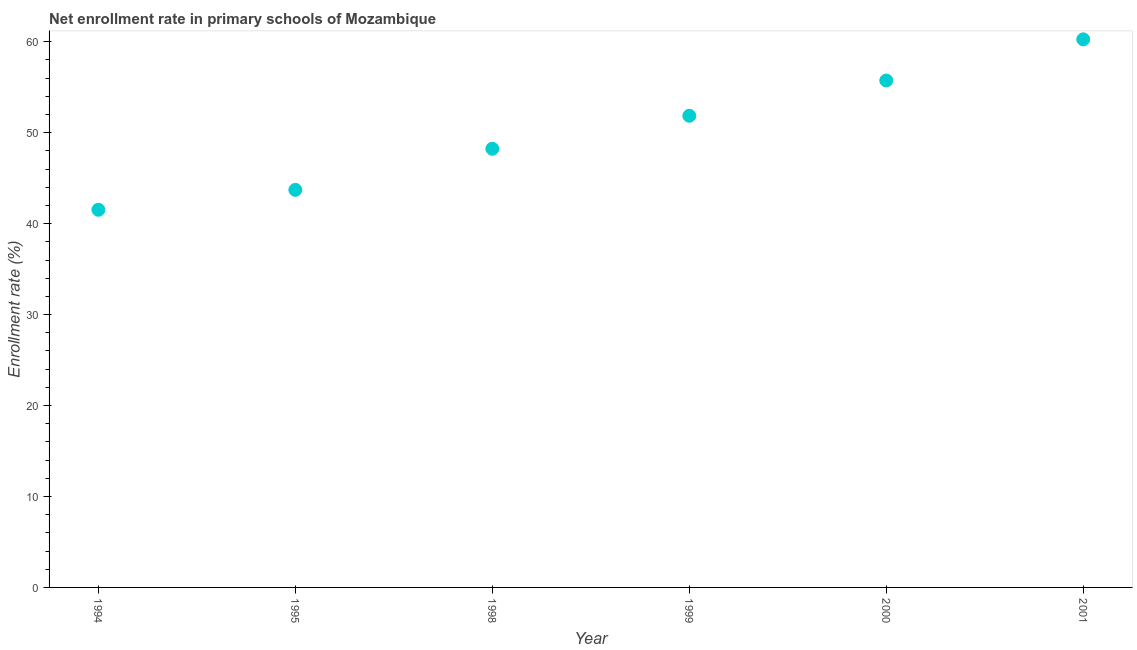What is the net enrollment rate in primary schools in 2001?
Your response must be concise. 60.26. Across all years, what is the maximum net enrollment rate in primary schools?
Your answer should be compact. 60.26. Across all years, what is the minimum net enrollment rate in primary schools?
Ensure brevity in your answer.  41.53. In which year was the net enrollment rate in primary schools minimum?
Provide a short and direct response. 1994. What is the sum of the net enrollment rate in primary schools?
Your response must be concise. 301.33. What is the difference between the net enrollment rate in primary schools in 1994 and 1999?
Your answer should be very brief. -10.34. What is the average net enrollment rate in primary schools per year?
Give a very brief answer. 50.22. What is the median net enrollment rate in primary schools?
Provide a short and direct response. 50.05. What is the ratio of the net enrollment rate in primary schools in 2000 to that in 2001?
Provide a short and direct response. 0.92. Is the net enrollment rate in primary schools in 1994 less than that in 2001?
Offer a terse response. Yes. What is the difference between the highest and the second highest net enrollment rate in primary schools?
Give a very brief answer. 4.53. What is the difference between the highest and the lowest net enrollment rate in primary schools?
Provide a short and direct response. 18.74. In how many years, is the net enrollment rate in primary schools greater than the average net enrollment rate in primary schools taken over all years?
Keep it short and to the point. 3. How many dotlines are there?
Offer a very short reply. 1. How many years are there in the graph?
Offer a very short reply. 6. What is the difference between two consecutive major ticks on the Y-axis?
Give a very brief answer. 10. Are the values on the major ticks of Y-axis written in scientific E-notation?
Make the answer very short. No. Does the graph contain any zero values?
Provide a short and direct response. No. Does the graph contain grids?
Make the answer very short. No. What is the title of the graph?
Provide a short and direct response. Net enrollment rate in primary schools of Mozambique. What is the label or title of the Y-axis?
Offer a terse response. Enrollment rate (%). What is the Enrollment rate (%) in 1994?
Provide a succinct answer. 41.53. What is the Enrollment rate (%) in 1995?
Ensure brevity in your answer.  43.71. What is the Enrollment rate (%) in 1998?
Your answer should be very brief. 48.23. What is the Enrollment rate (%) in 1999?
Give a very brief answer. 51.86. What is the Enrollment rate (%) in 2000?
Provide a succinct answer. 55.74. What is the Enrollment rate (%) in 2001?
Your answer should be compact. 60.26. What is the difference between the Enrollment rate (%) in 1994 and 1995?
Ensure brevity in your answer.  -2.19. What is the difference between the Enrollment rate (%) in 1994 and 1998?
Provide a short and direct response. -6.71. What is the difference between the Enrollment rate (%) in 1994 and 1999?
Offer a terse response. -10.34. What is the difference between the Enrollment rate (%) in 1994 and 2000?
Make the answer very short. -14.21. What is the difference between the Enrollment rate (%) in 1994 and 2001?
Your answer should be compact. -18.74. What is the difference between the Enrollment rate (%) in 1995 and 1998?
Your answer should be compact. -4.52. What is the difference between the Enrollment rate (%) in 1995 and 1999?
Your answer should be very brief. -8.15. What is the difference between the Enrollment rate (%) in 1995 and 2000?
Give a very brief answer. -12.02. What is the difference between the Enrollment rate (%) in 1995 and 2001?
Provide a succinct answer. -16.55. What is the difference between the Enrollment rate (%) in 1998 and 1999?
Ensure brevity in your answer.  -3.63. What is the difference between the Enrollment rate (%) in 1998 and 2000?
Ensure brevity in your answer.  -7.5. What is the difference between the Enrollment rate (%) in 1998 and 2001?
Make the answer very short. -12.03. What is the difference between the Enrollment rate (%) in 1999 and 2000?
Make the answer very short. -3.87. What is the difference between the Enrollment rate (%) in 1999 and 2001?
Keep it short and to the point. -8.4. What is the difference between the Enrollment rate (%) in 2000 and 2001?
Your response must be concise. -4.53. What is the ratio of the Enrollment rate (%) in 1994 to that in 1998?
Provide a short and direct response. 0.86. What is the ratio of the Enrollment rate (%) in 1994 to that in 1999?
Ensure brevity in your answer.  0.8. What is the ratio of the Enrollment rate (%) in 1994 to that in 2000?
Your answer should be compact. 0.74. What is the ratio of the Enrollment rate (%) in 1994 to that in 2001?
Make the answer very short. 0.69. What is the ratio of the Enrollment rate (%) in 1995 to that in 1998?
Make the answer very short. 0.91. What is the ratio of the Enrollment rate (%) in 1995 to that in 1999?
Your response must be concise. 0.84. What is the ratio of the Enrollment rate (%) in 1995 to that in 2000?
Your answer should be compact. 0.78. What is the ratio of the Enrollment rate (%) in 1995 to that in 2001?
Make the answer very short. 0.72. What is the ratio of the Enrollment rate (%) in 1998 to that in 2000?
Your answer should be compact. 0.86. What is the ratio of the Enrollment rate (%) in 1999 to that in 2000?
Ensure brevity in your answer.  0.93. What is the ratio of the Enrollment rate (%) in 1999 to that in 2001?
Your response must be concise. 0.86. What is the ratio of the Enrollment rate (%) in 2000 to that in 2001?
Keep it short and to the point. 0.93. 